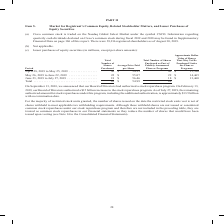According to Cisco Systems's financial document, When did the Board of Directors authorize an increase to the stock repurchase program? On February 13, 2019, our Board of Directors authorized a $15 billion increase to the stock repurchase program.. The document states: "rectors had authorized a stock repurchase program. On February 13, 2019, our Board of Directors authorized a $15 billion increase to the stock repurch..." Also, Where is Cisco common stock traded under? Cisco common stock is traded on the Nasdaq Global Select Market under the symbol CSCO.. The document states: "(a) Cisco common stock is traded on the Nasdaq Global Select Market under the symbol CSCO. Information regarding quarterly cash dividends declared on ..." Also, How many shareholders were there as of August 30, 2019? There were 39,216 registered shareholders as of August 30, 2019. The document states: "entary Financial Data on page 106 of this report. There were 39,216 registered shareholders as of August 30, 2019...." Also, can you calculate: What was the total amount paid for the shares during the period from April 28, 2019 to May 25, 2019 and May 26, 2019 to June 22, 2019? Based on the calculation: (42*54.33)+(22*55.07), the result is 3493.4 (in millions). This is based on the information: "019 . 42 $ 54.33 42 $ 15,700 May 26, 2019 to June 22, 2019 . 22 $ 55.07 22 $ 14,465 June 23, 2019 to July 27, 2019 . 18 $ 56.46 18 $ 13,460 Total . 82 $ lans or Programs April 28, 2019 to May 25, 2019..." The key data points involved are: 22, 42, 54.33. Also, can you calculate: What was the average total amount paid for the shares during the period from April 28, 2019 to May 25, 2019 and May 26, 2019 to June 22, 2019? To answer this question, I need to perform calculations using the financial data. The calculation is: ((42*54.33)+(22*55.07))/2, which equals 1746.7 (in millions). This is based on the information: "42 $ 15,700 May 26, 2019 to June 22, 2019 . 22 $ 55.07 22 $ 14,465 June 23, 2019 to July 27, 2019 . 18 $ 56.46 18 $ 13,460 Total . 82 $ 54.99 82 019 . 42 $ 54.33 42 $ 15,700 May 26, 2019 to June 22, 2..." The key data points involved are: 2, 22, 42. Also, can you calculate: What is the average of Average Price Paid per Share in the three period?  To answer this question, I need to perform calculations using the financial data. The calculation is: ($54.33+$55.07+$56.46)/3, which equals 55.29. This is based on the information: "or Programs April 28, 2019 to May 25, 2019 . 42 $ 54.33 42 $ 15,700 May 26, 2019 to June 22, 2019 . 22 $ 55.07 22 $ 14,465 June 23, 2019 to July 27, 2019 . 22 $ 14,465 June 23, 2019 to July 27, 2019 ...." The key data points involved are: 54.33, 55.07, 56.46. 